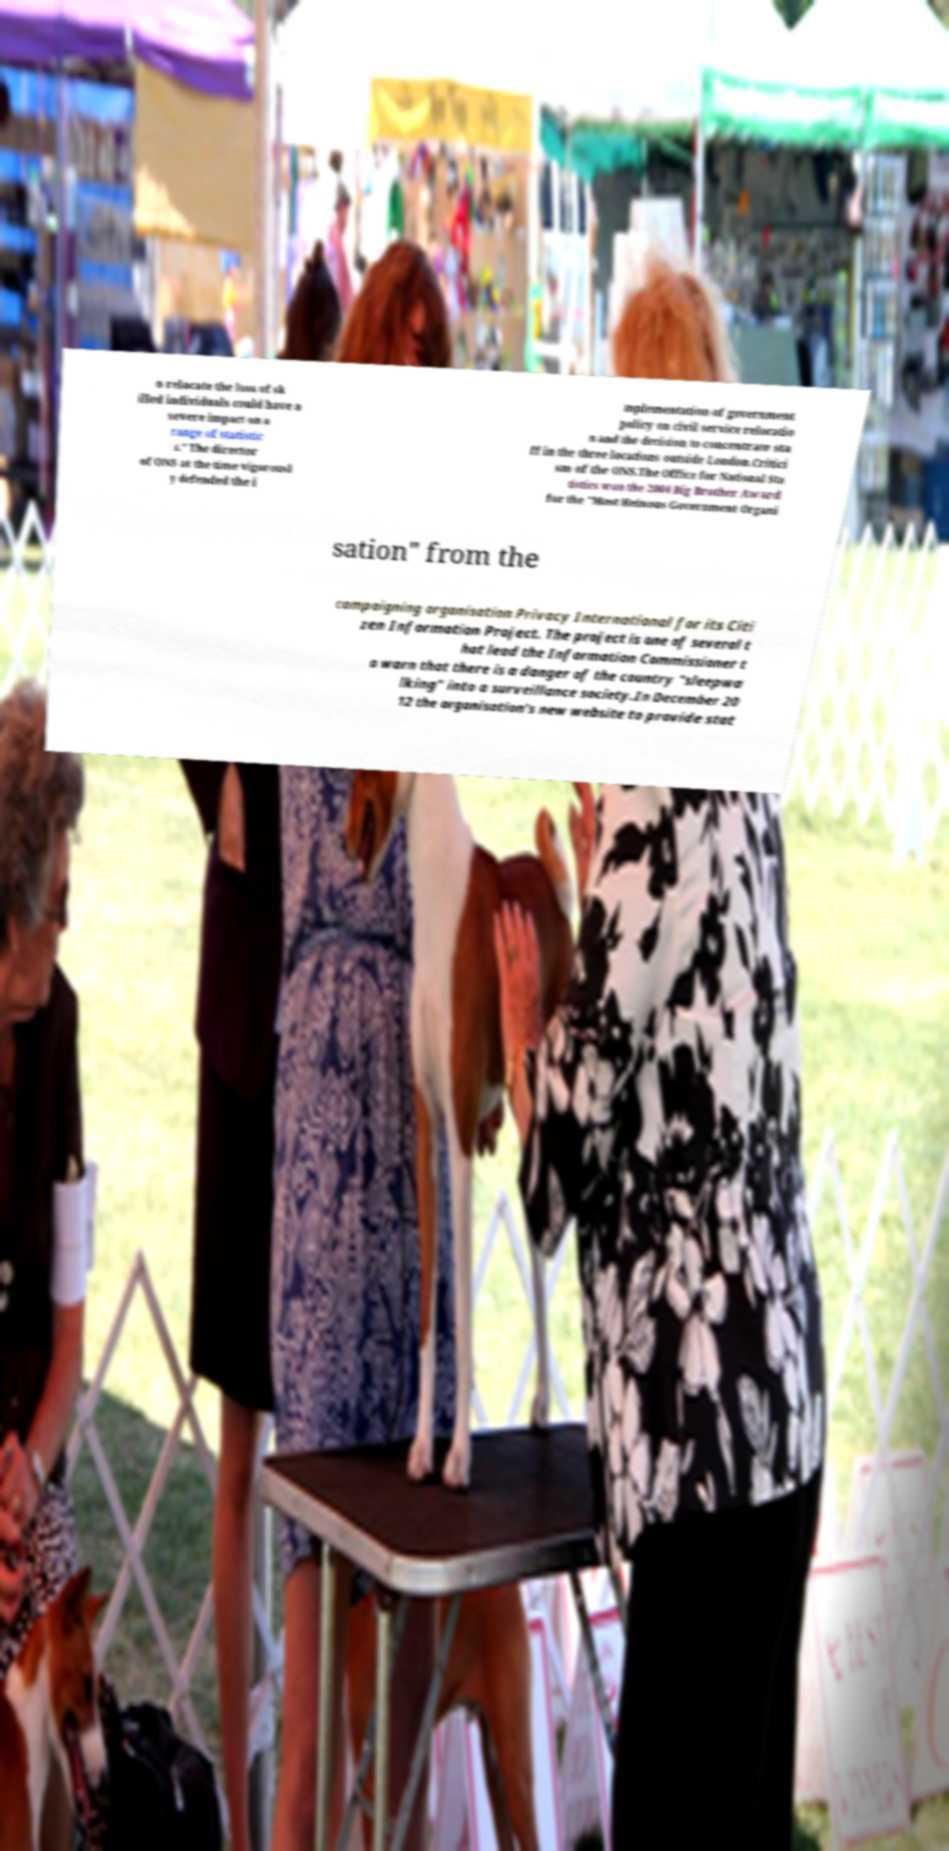Could you extract and type out the text from this image? o relocate the loss of sk illed individuals could have a severe impact on a range of statistic s." The director of ONS at the time vigorousl y defended the i mplementation of government policy on civil service relocatio n and the decision to concentrate sta ff in the three locations outside London.Critici sm of the ONS.The Office for National Sta tistics won the 2004 Big Brother Award for the "Most Heinous Government Organi sation" from the campaigning organisation Privacy International for its Citi zen Information Project. The project is one of several t hat lead the Information Commissioner t o warn that there is a danger of the country "sleepwa lking" into a surveillance society.In December 20 12 the organisation's new website to provide stat 